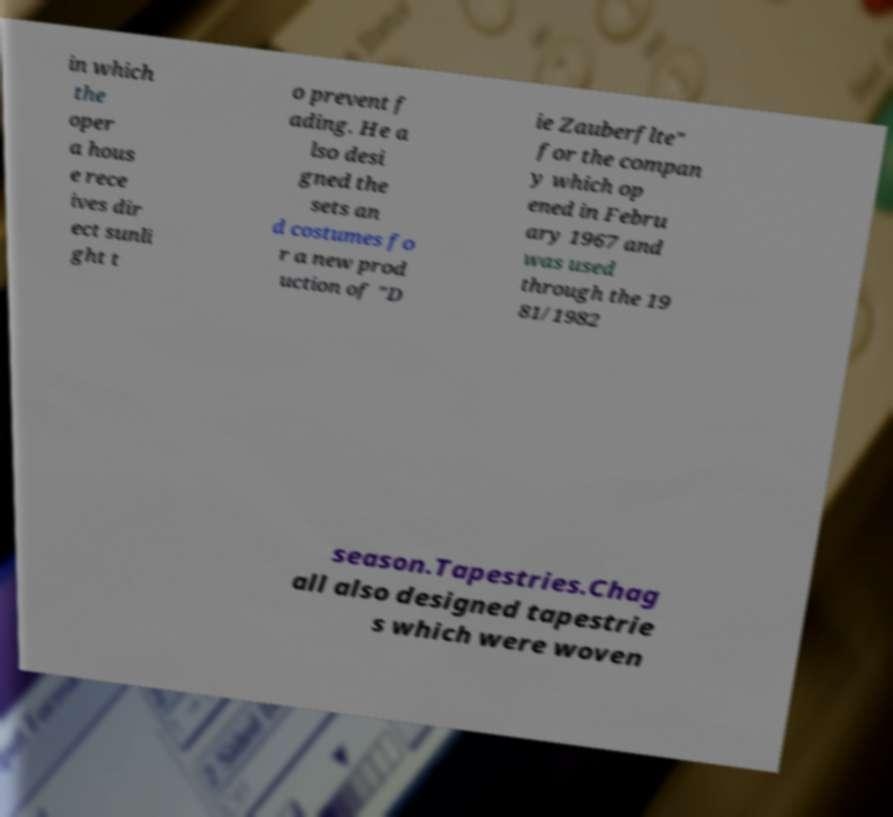Can you read and provide the text displayed in the image?This photo seems to have some interesting text. Can you extract and type it out for me? in which the oper a hous e rece ives dir ect sunli ght t o prevent f ading. He a lso desi gned the sets an d costumes fo r a new prod uction of "D ie Zauberflte" for the compan y which op ened in Febru ary 1967 and was used through the 19 81/1982 season.Tapestries.Chag all also designed tapestrie s which were woven 